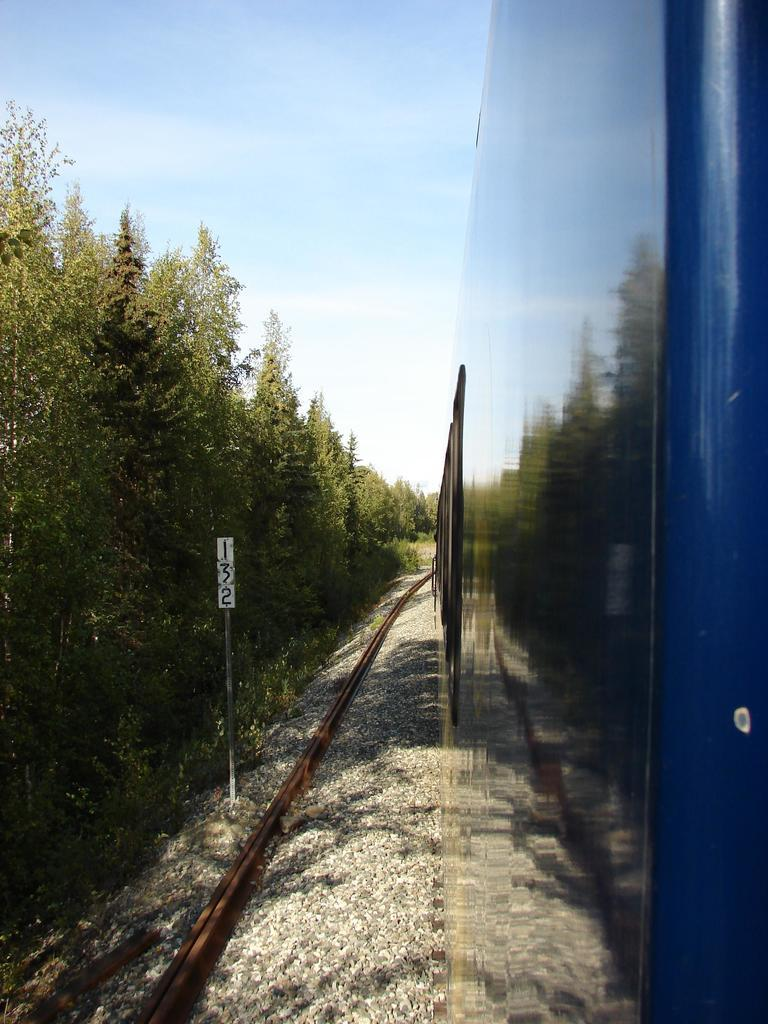What is the main subject in the foreground of the image? There is a train in the foreground of the image on the right side. What is the train's position in relation to the image? The train is on a track. What type of vegetation can be seen on the left side of the image? There are trees on the left side of the image. What is visible at the top of the image? The sky is visible at the top of the image, and there are clouds in the sky. What type of waves can be seen in the image? There are no waves present in the image; it features a train on a track with trees and a sky with clouds. How is the butter used in the image? There is no butter present in the image. 